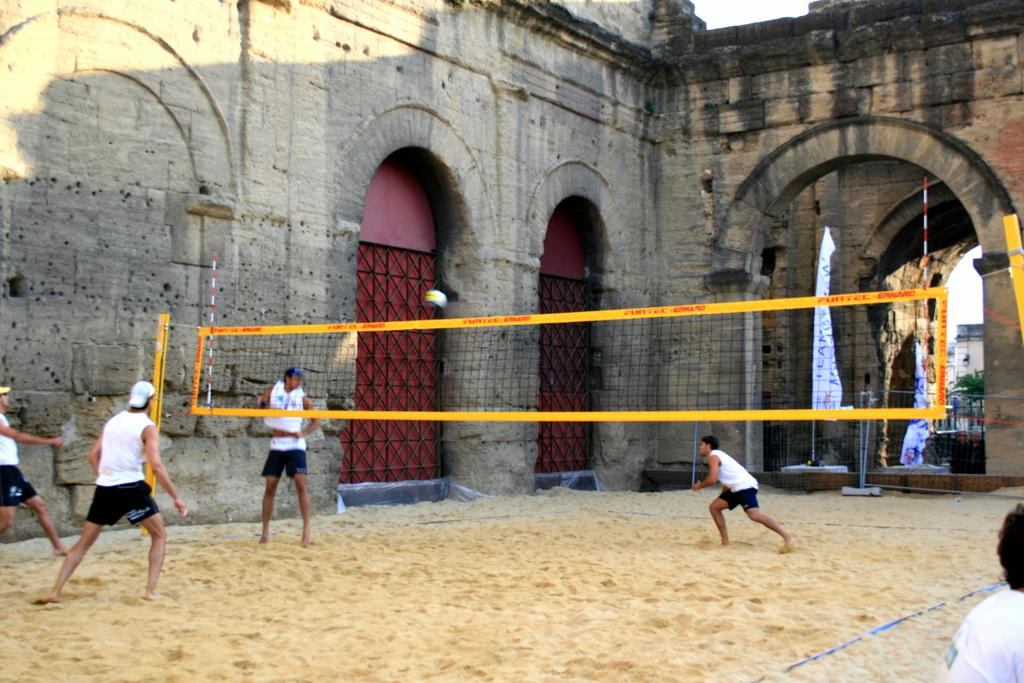What is the main structure in the middle of the image? There is a building in the middle of the image. What else can be seen in the middle of the image? There is a net in the middle of the image. What are the people in the image doing? The people in the image are playing. What type of operation is being performed on the building in the image? There is no operation being performed on the building in the image; it appears to be a regular structure. 